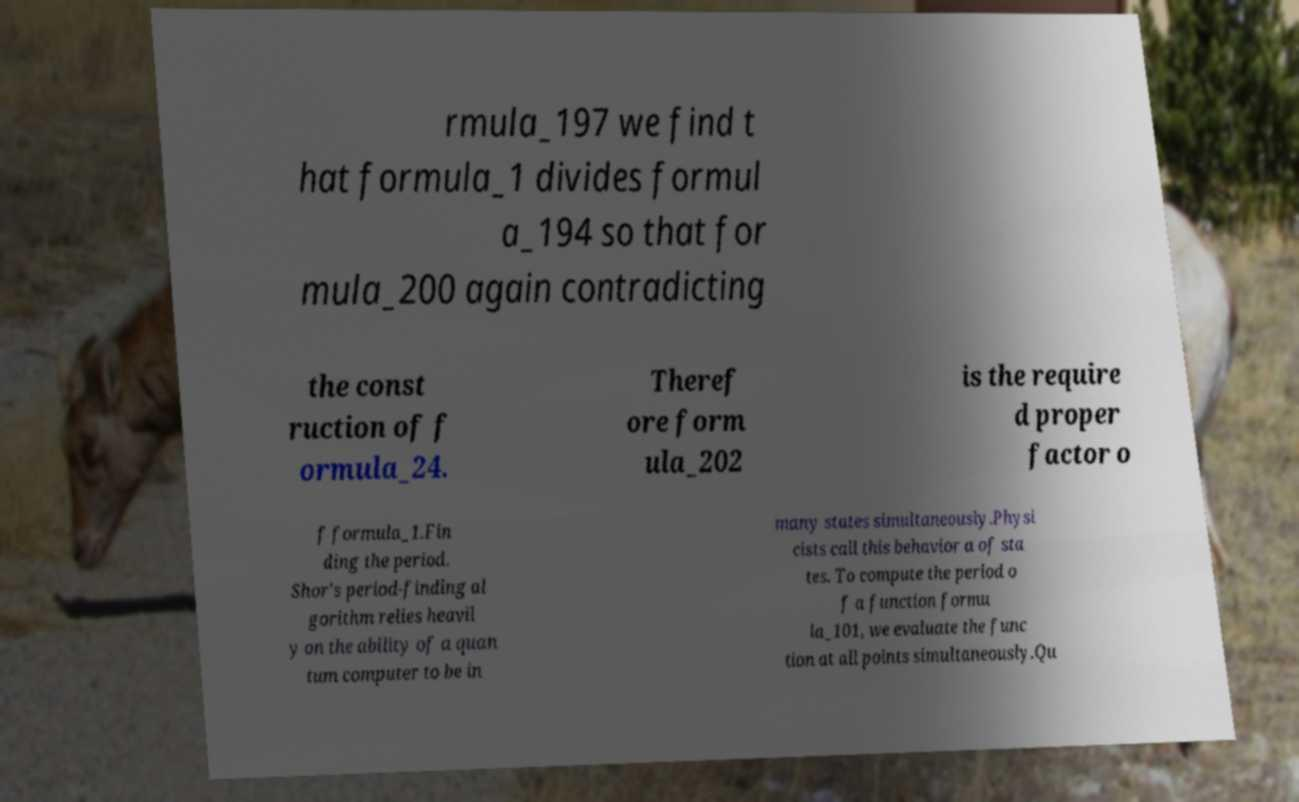Please identify and transcribe the text found in this image. rmula_197 we find t hat formula_1 divides formul a_194 so that for mula_200 again contradicting the const ruction of f ormula_24. Theref ore form ula_202 is the require d proper factor o f formula_1.Fin ding the period. Shor's period-finding al gorithm relies heavil y on the ability of a quan tum computer to be in many states simultaneously.Physi cists call this behavior a of sta tes. To compute the period o f a function formu la_101, we evaluate the func tion at all points simultaneously.Qu 